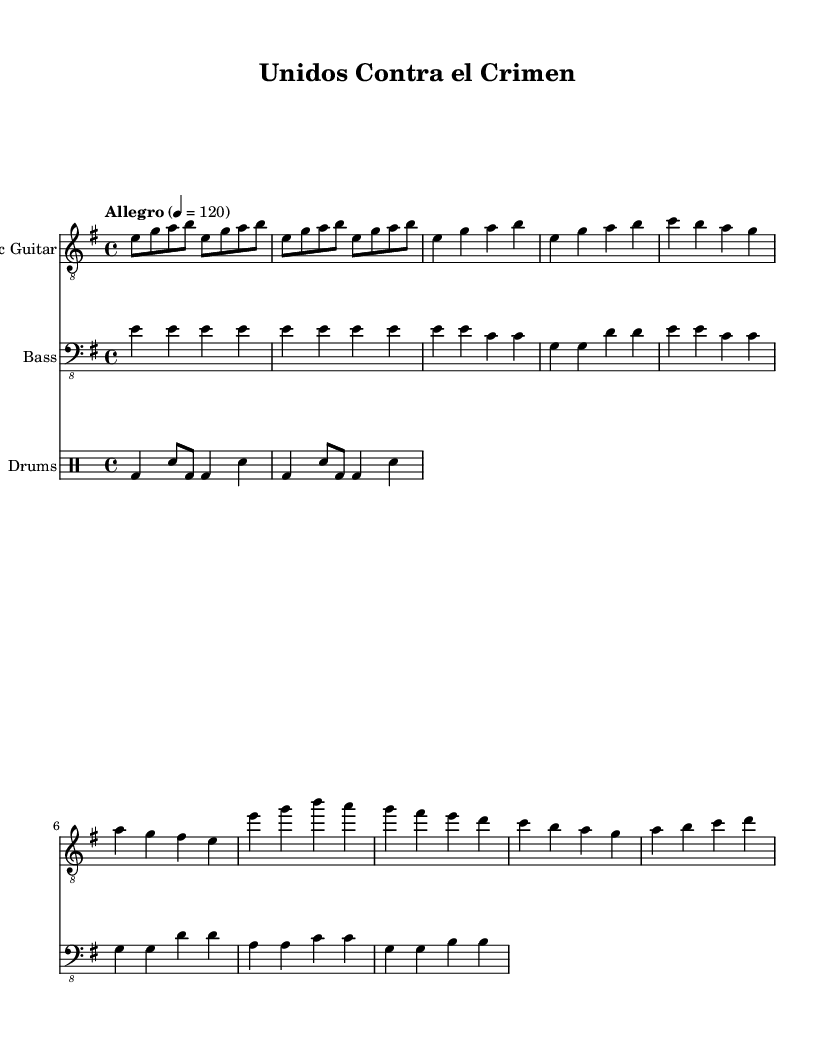What is the key signature of this music? The key signature is E minor, which has one sharp (F#). The key signature is visible at the beginning of the staff, indicating the notes that will be sharp in this piece.
Answer: E minor What is the time signature of this music? The time signature is 4/4, which indicates that there are four beats in each measure and a quarter note receives one beat. This can be identified at the beginning of the score where the 4/4 is written.
Answer: 4/4 What is the tempo indication of this music? The tempo is marked "Allegro," which means a fast, lively pace. The number 120 indicates the beats per minute, specifying the speed at which the piece should be played. This can be found next to the tempo marking at the beginning of the score.
Answer: Allegro How many measures are in the verse section? The verse section has four measures in total. This can be seen by counting each group of music notation lines from the start of the verse to where it ends within the score.
Answer: Four What type of rhythm style is used in the drums? The rhythm style resembles a basic rock beat with Latin accents. This combination is typical in Latin rock, incorporating a standard drum pattern with additional rhythmic flair that enhances the Latin influence. It can be identified by the use of bass drum and snare configurations in the drum part.
Answer: Latin rock beat What is the highest note in the chorus? The highest note in the chorus is D. By analyzing the notes in the chorus section of the electric guitar part, D is the highest note reached during the phrasing of the music.
Answer: D What instrument plays the bass part? The bass part is performed on the bass guitar, which is indicated at the beginning of that staff section in the sheet music. The clef used is the bass clef, confirming the bass guitar's role in this arrangement.
Answer: Bass guitar 